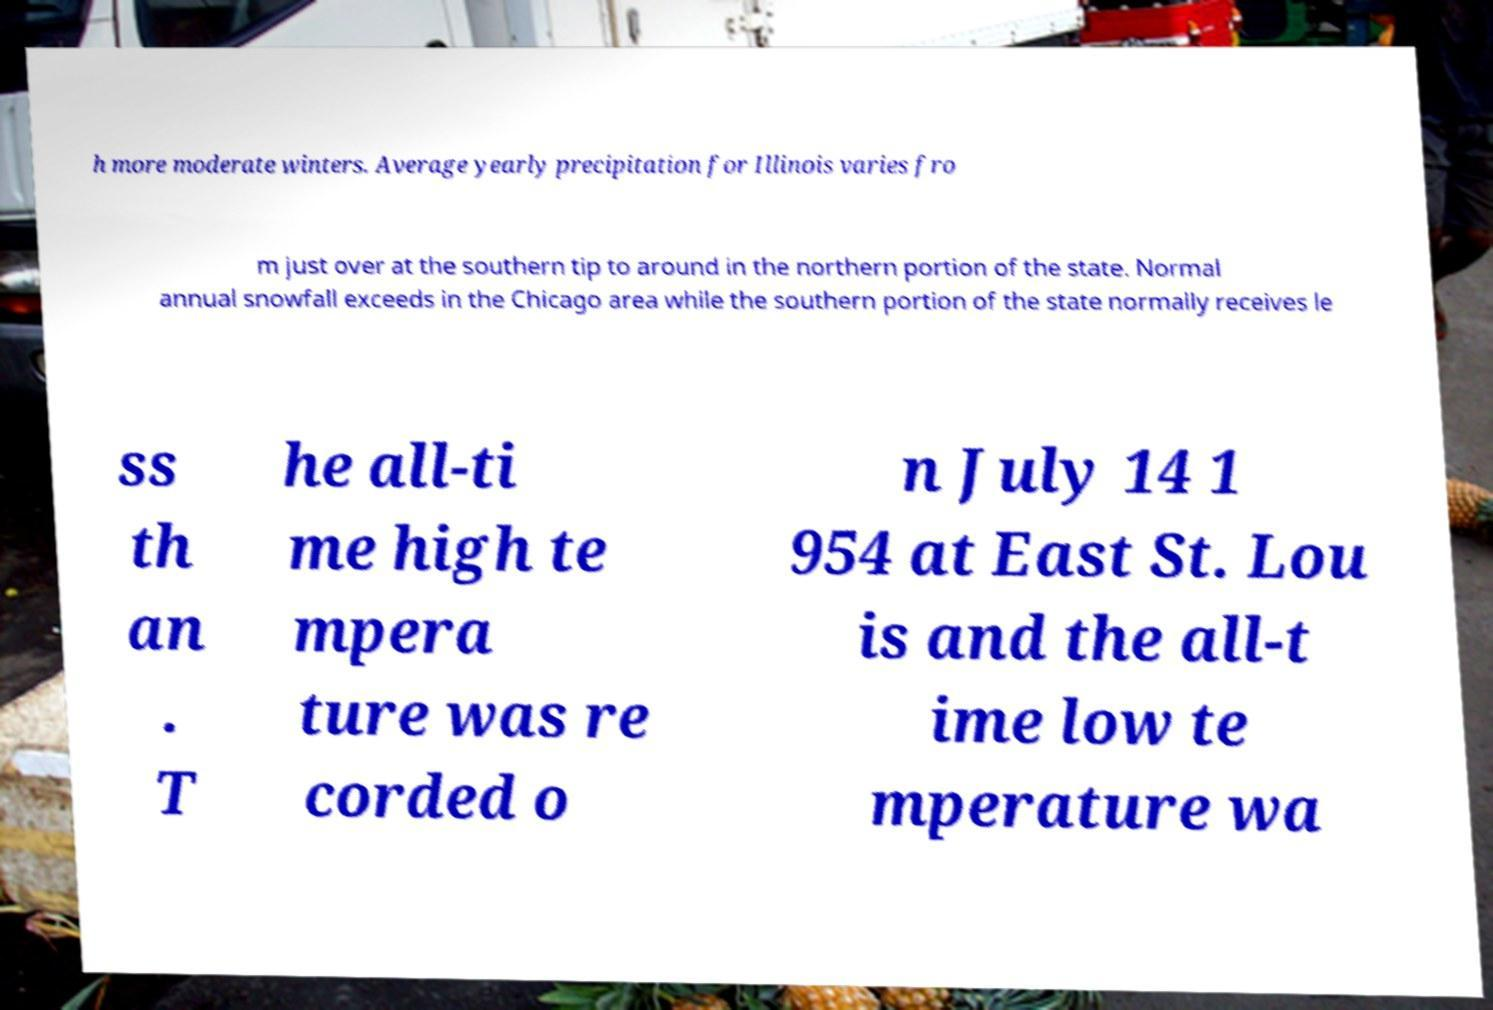Can you accurately transcribe the text from the provided image for me? h more moderate winters. Average yearly precipitation for Illinois varies fro m just over at the southern tip to around in the northern portion of the state. Normal annual snowfall exceeds in the Chicago area while the southern portion of the state normally receives le ss th an . T he all-ti me high te mpera ture was re corded o n July 14 1 954 at East St. Lou is and the all-t ime low te mperature wa 